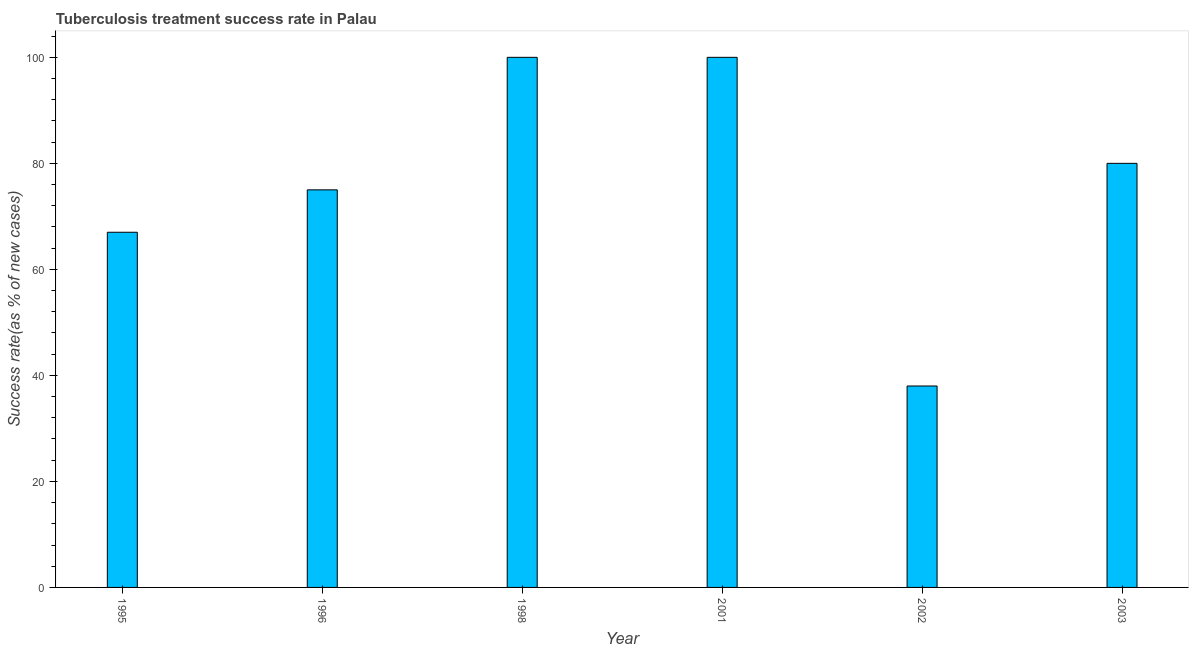Does the graph contain any zero values?
Offer a very short reply. No. Does the graph contain grids?
Provide a short and direct response. No. What is the title of the graph?
Ensure brevity in your answer.  Tuberculosis treatment success rate in Palau. What is the label or title of the X-axis?
Your answer should be very brief. Year. What is the label or title of the Y-axis?
Offer a terse response. Success rate(as % of new cases). In which year was the tuberculosis treatment success rate maximum?
Your answer should be very brief. 1998. In which year was the tuberculosis treatment success rate minimum?
Your response must be concise. 2002. What is the sum of the tuberculosis treatment success rate?
Give a very brief answer. 460. What is the median tuberculosis treatment success rate?
Provide a succinct answer. 77.5. In how many years, is the tuberculosis treatment success rate greater than 64 %?
Your answer should be very brief. 5. Do a majority of the years between 1998 and 1995 (inclusive) have tuberculosis treatment success rate greater than 72 %?
Ensure brevity in your answer.  Yes. What is the ratio of the tuberculosis treatment success rate in 1995 to that in 1998?
Offer a terse response. 0.67. Is the tuberculosis treatment success rate in 1995 less than that in 1998?
Provide a succinct answer. Yes. Is the sum of the tuberculosis treatment success rate in 2001 and 2002 greater than the maximum tuberculosis treatment success rate across all years?
Make the answer very short. Yes. What is the difference between the highest and the lowest tuberculosis treatment success rate?
Make the answer very short. 62. In how many years, is the tuberculosis treatment success rate greater than the average tuberculosis treatment success rate taken over all years?
Provide a short and direct response. 3. How many bars are there?
Offer a very short reply. 6. How many years are there in the graph?
Your answer should be very brief. 6. What is the Success rate(as % of new cases) in 1996?
Provide a succinct answer. 75. What is the Success rate(as % of new cases) of 1998?
Provide a short and direct response. 100. What is the Success rate(as % of new cases) in 2002?
Offer a very short reply. 38. What is the Success rate(as % of new cases) in 2003?
Offer a terse response. 80. What is the difference between the Success rate(as % of new cases) in 1995 and 1998?
Provide a short and direct response. -33. What is the difference between the Success rate(as % of new cases) in 1995 and 2001?
Your answer should be compact. -33. What is the difference between the Success rate(as % of new cases) in 1995 and 2003?
Provide a succinct answer. -13. What is the difference between the Success rate(as % of new cases) in 1996 and 2001?
Keep it short and to the point. -25. What is the difference between the Success rate(as % of new cases) in 1996 and 2003?
Provide a short and direct response. -5. What is the difference between the Success rate(as % of new cases) in 2001 and 2003?
Provide a short and direct response. 20. What is the difference between the Success rate(as % of new cases) in 2002 and 2003?
Keep it short and to the point. -42. What is the ratio of the Success rate(as % of new cases) in 1995 to that in 1996?
Keep it short and to the point. 0.89. What is the ratio of the Success rate(as % of new cases) in 1995 to that in 1998?
Provide a succinct answer. 0.67. What is the ratio of the Success rate(as % of new cases) in 1995 to that in 2001?
Offer a very short reply. 0.67. What is the ratio of the Success rate(as % of new cases) in 1995 to that in 2002?
Give a very brief answer. 1.76. What is the ratio of the Success rate(as % of new cases) in 1995 to that in 2003?
Offer a terse response. 0.84. What is the ratio of the Success rate(as % of new cases) in 1996 to that in 2002?
Offer a very short reply. 1.97. What is the ratio of the Success rate(as % of new cases) in 1996 to that in 2003?
Offer a terse response. 0.94. What is the ratio of the Success rate(as % of new cases) in 1998 to that in 2002?
Offer a very short reply. 2.63. What is the ratio of the Success rate(as % of new cases) in 2001 to that in 2002?
Give a very brief answer. 2.63. What is the ratio of the Success rate(as % of new cases) in 2002 to that in 2003?
Offer a very short reply. 0.47. 